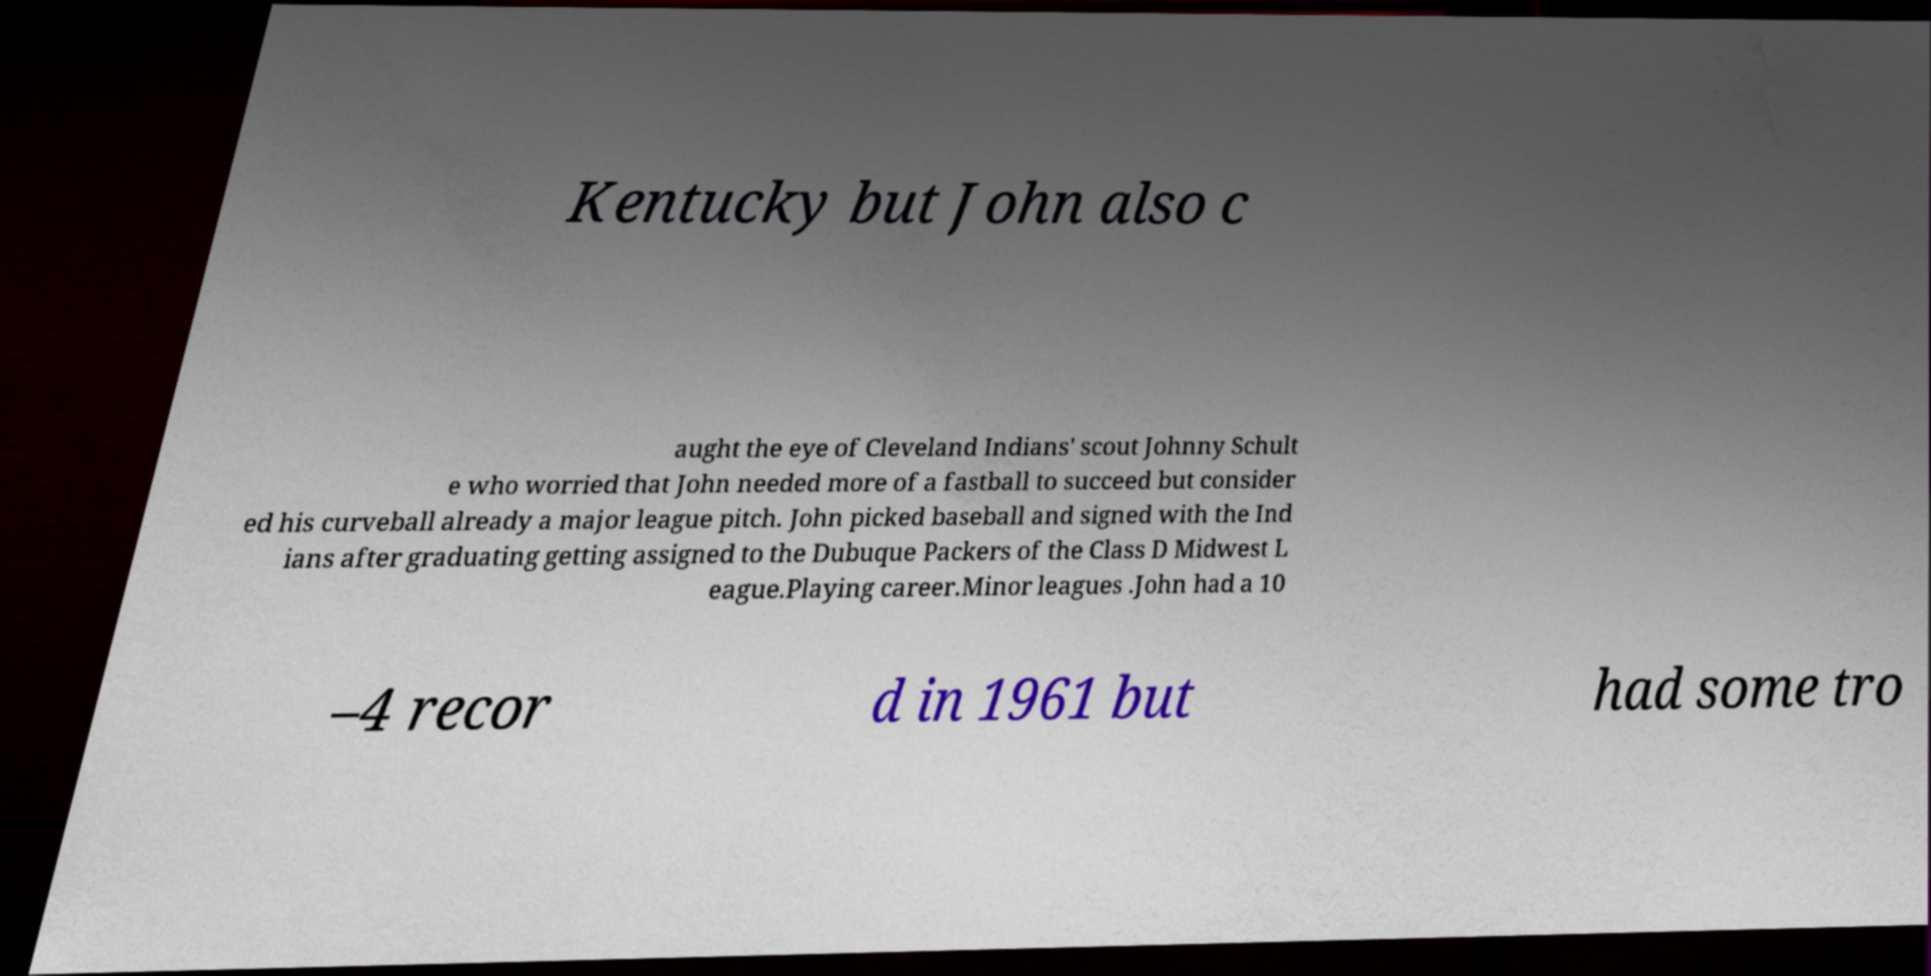Could you extract and type out the text from this image? Kentucky but John also c aught the eye of Cleveland Indians' scout Johnny Schult e who worried that John needed more of a fastball to succeed but consider ed his curveball already a major league pitch. John picked baseball and signed with the Ind ians after graduating getting assigned to the Dubuque Packers of the Class D Midwest L eague.Playing career.Minor leagues .John had a 10 –4 recor d in 1961 but had some tro 